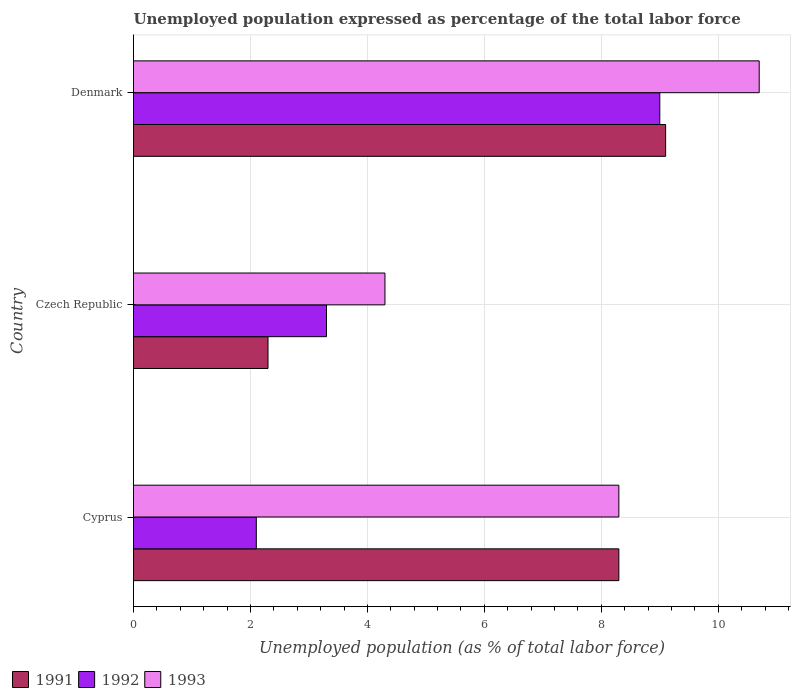How many groups of bars are there?
Your answer should be compact. 3. Are the number of bars per tick equal to the number of legend labels?
Offer a very short reply. Yes. How many bars are there on the 3rd tick from the bottom?
Offer a terse response. 3. What is the label of the 3rd group of bars from the top?
Make the answer very short. Cyprus. Across all countries, what is the maximum unemployment in in 1993?
Offer a terse response. 10.7. Across all countries, what is the minimum unemployment in in 1992?
Provide a short and direct response. 2.1. In which country was the unemployment in in 1992 minimum?
Your answer should be very brief. Cyprus. What is the total unemployment in in 1992 in the graph?
Provide a short and direct response. 14.4. What is the difference between the unemployment in in 1992 in Cyprus and that in Czech Republic?
Ensure brevity in your answer.  -1.2. What is the difference between the unemployment in in 1993 in Czech Republic and the unemployment in in 1992 in Cyprus?
Ensure brevity in your answer.  2.2. What is the average unemployment in in 1992 per country?
Give a very brief answer. 4.8. What is the difference between the unemployment in in 1991 and unemployment in in 1993 in Denmark?
Keep it short and to the point. -1.6. What is the ratio of the unemployment in in 1992 in Cyprus to that in Czech Republic?
Provide a short and direct response. 0.64. What is the difference between the highest and the second highest unemployment in in 1992?
Your response must be concise. 5.7. What is the difference between the highest and the lowest unemployment in in 1992?
Offer a terse response. 6.9. In how many countries, is the unemployment in in 1992 greater than the average unemployment in in 1992 taken over all countries?
Offer a terse response. 1. What does the 1st bar from the top in Czech Republic represents?
Offer a very short reply. 1993. What does the 1st bar from the bottom in Czech Republic represents?
Your response must be concise. 1991. Is it the case that in every country, the sum of the unemployment in in 1993 and unemployment in in 1991 is greater than the unemployment in in 1992?
Offer a very short reply. Yes. How many countries are there in the graph?
Make the answer very short. 3. Does the graph contain grids?
Your response must be concise. Yes. What is the title of the graph?
Provide a short and direct response. Unemployed population expressed as percentage of the total labor force. Does "1997" appear as one of the legend labels in the graph?
Your response must be concise. No. What is the label or title of the X-axis?
Keep it short and to the point. Unemployed population (as % of total labor force). What is the label or title of the Y-axis?
Offer a terse response. Country. What is the Unemployed population (as % of total labor force) in 1991 in Cyprus?
Your answer should be very brief. 8.3. What is the Unemployed population (as % of total labor force) in 1992 in Cyprus?
Offer a very short reply. 2.1. What is the Unemployed population (as % of total labor force) in 1993 in Cyprus?
Give a very brief answer. 8.3. What is the Unemployed population (as % of total labor force) of 1991 in Czech Republic?
Offer a very short reply. 2.3. What is the Unemployed population (as % of total labor force) of 1992 in Czech Republic?
Give a very brief answer. 3.3. What is the Unemployed population (as % of total labor force) in 1993 in Czech Republic?
Keep it short and to the point. 4.3. What is the Unemployed population (as % of total labor force) of 1991 in Denmark?
Make the answer very short. 9.1. What is the Unemployed population (as % of total labor force) of 1992 in Denmark?
Keep it short and to the point. 9. What is the Unemployed population (as % of total labor force) of 1993 in Denmark?
Give a very brief answer. 10.7. Across all countries, what is the maximum Unemployed population (as % of total labor force) of 1991?
Offer a terse response. 9.1. Across all countries, what is the maximum Unemployed population (as % of total labor force) in 1993?
Provide a succinct answer. 10.7. Across all countries, what is the minimum Unemployed population (as % of total labor force) in 1991?
Provide a succinct answer. 2.3. Across all countries, what is the minimum Unemployed population (as % of total labor force) in 1992?
Keep it short and to the point. 2.1. Across all countries, what is the minimum Unemployed population (as % of total labor force) of 1993?
Your answer should be very brief. 4.3. What is the total Unemployed population (as % of total labor force) in 1992 in the graph?
Keep it short and to the point. 14.4. What is the total Unemployed population (as % of total labor force) of 1993 in the graph?
Provide a short and direct response. 23.3. What is the difference between the Unemployed population (as % of total labor force) in 1992 in Cyprus and that in Czech Republic?
Your answer should be compact. -1.2. What is the difference between the Unemployed population (as % of total labor force) of 1993 in Cyprus and that in Denmark?
Your answer should be compact. -2.4. What is the difference between the Unemployed population (as % of total labor force) in 1991 in Czech Republic and that in Denmark?
Your answer should be very brief. -6.8. What is the difference between the Unemployed population (as % of total labor force) of 1992 in Czech Republic and that in Denmark?
Ensure brevity in your answer.  -5.7. What is the difference between the Unemployed population (as % of total labor force) in 1991 in Cyprus and the Unemployed population (as % of total labor force) in 1992 in Czech Republic?
Your answer should be compact. 5. What is the difference between the Unemployed population (as % of total labor force) in 1991 in Cyprus and the Unemployed population (as % of total labor force) in 1993 in Czech Republic?
Ensure brevity in your answer.  4. What is the difference between the Unemployed population (as % of total labor force) of 1991 in Cyprus and the Unemployed population (as % of total labor force) of 1993 in Denmark?
Keep it short and to the point. -2.4. What is the difference between the Unemployed population (as % of total labor force) of 1992 in Cyprus and the Unemployed population (as % of total labor force) of 1993 in Denmark?
Ensure brevity in your answer.  -8.6. What is the difference between the Unemployed population (as % of total labor force) of 1992 in Czech Republic and the Unemployed population (as % of total labor force) of 1993 in Denmark?
Keep it short and to the point. -7.4. What is the average Unemployed population (as % of total labor force) in 1991 per country?
Ensure brevity in your answer.  6.57. What is the average Unemployed population (as % of total labor force) in 1992 per country?
Keep it short and to the point. 4.8. What is the average Unemployed population (as % of total labor force) of 1993 per country?
Provide a short and direct response. 7.77. What is the difference between the Unemployed population (as % of total labor force) of 1991 and Unemployed population (as % of total labor force) of 1992 in Cyprus?
Ensure brevity in your answer.  6.2. What is the difference between the Unemployed population (as % of total labor force) of 1991 and Unemployed population (as % of total labor force) of 1993 in Cyprus?
Keep it short and to the point. 0. What is the difference between the Unemployed population (as % of total labor force) in 1991 and Unemployed population (as % of total labor force) in 1993 in Czech Republic?
Provide a succinct answer. -2. What is the difference between the Unemployed population (as % of total labor force) of 1991 and Unemployed population (as % of total labor force) of 1993 in Denmark?
Ensure brevity in your answer.  -1.6. What is the ratio of the Unemployed population (as % of total labor force) in 1991 in Cyprus to that in Czech Republic?
Provide a short and direct response. 3.61. What is the ratio of the Unemployed population (as % of total labor force) of 1992 in Cyprus to that in Czech Republic?
Make the answer very short. 0.64. What is the ratio of the Unemployed population (as % of total labor force) in 1993 in Cyprus to that in Czech Republic?
Keep it short and to the point. 1.93. What is the ratio of the Unemployed population (as % of total labor force) in 1991 in Cyprus to that in Denmark?
Provide a short and direct response. 0.91. What is the ratio of the Unemployed population (as % of total labor force) of 1992 in Cyprus to that in Denmark?
Provide a short and direct response. 0.23. What is the ratio of the Unemployed population (as % of total labor force) in 1993 in Cyprus to that in Denmark?
Make the answer very short. 0.78. What is the ratio of the Unemployed population (as % of total labor force) in 1991 in Czech Republic to that in Denmark?
Give a very brief answer. 0.25. What is the ratio of the Unemployed population (as % of total labor force) in 1992 in Czech Republic to that in Denmark?
Make the answer very short. 0.37. What is the ratio of the Unemployed population (as % of total labor force) of 1993 in Czech Republic to that in Denmark?
Offer a very short reply. 0.4. What is the difference between the highest and the second highest Unemployed population (as % of total labor force) of 1991?
Your answer should be very brief. 0.8. What is the difference between the highest and the lowest Unemployed population (as % of total labor force) of 1992?
Offer a very short reply. 6.9. What is the difference between the highest and the lowest Unemployed population (as % of total labor force) of 1993?
Keep it short and to the point. 6.4. 